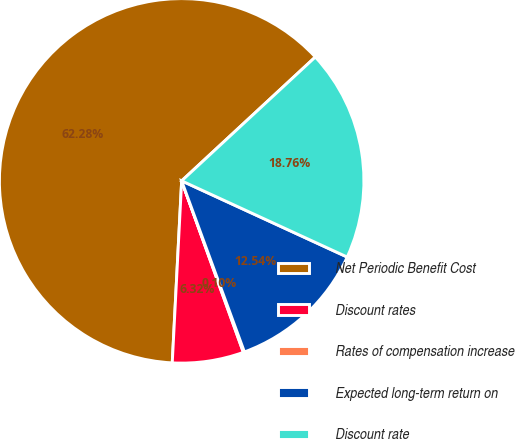Convert chart. <chart><loc_0><loc_0><loc_500><loc_500><pie_chart><fcel>Net Periodic Benefit Cost<fcel>Discount rates<fcel>Rates of compensation increase<fcel>Expected long-term return on<fcel>Discount rate<nl><fcel>62.29%<fcel>6.32%<fcel>0.1%<fcel>12.54%<fcel>18.76%<nl></chart> 